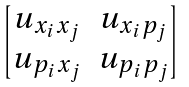Convert formula to latex. <formula><loc_0><loc_0><loc_500><loc_500>\begin{bmatrix} u _ { x _ { i } x _ { j } } & u _ { x _ { i } p _ { j } } \\ u _ { p _ { i } x _ { j } } & u _ { p _ { i } p _ { j } } \end{bmatrix}</formula> 